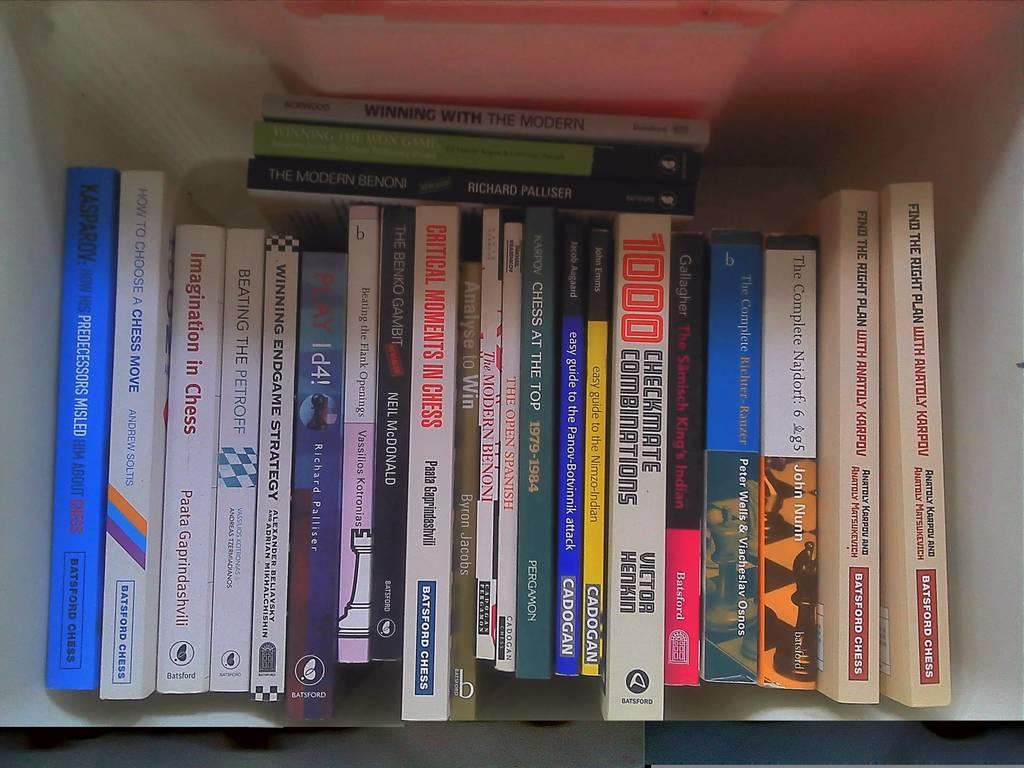What is the title of the book with the neon orange number on the spine?
Make the answer very short. Checkmate combinations. How many checkmate combinations are there?
Offer a terse response. 1000. 